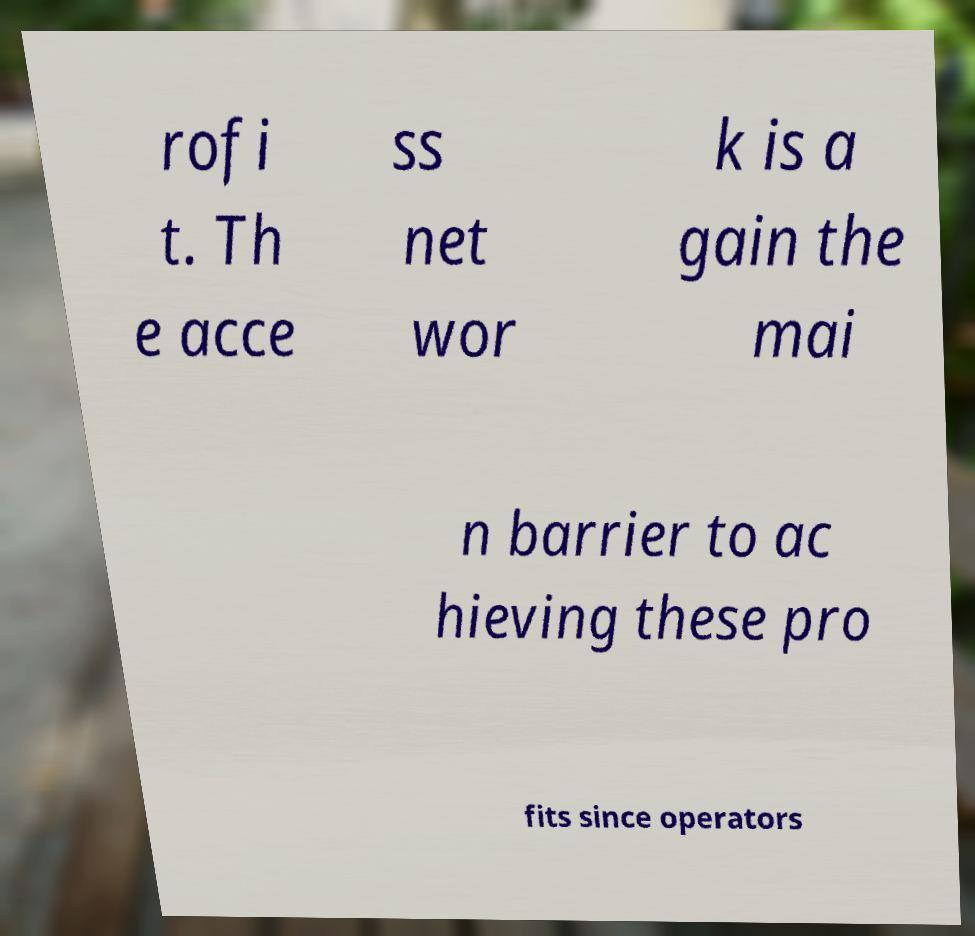I need the written content from this picture converted into text. Can you do that? rofi t. Th e acce ss net wor k is a gain the mai n barrier to ac hieving these pro fits since operators 